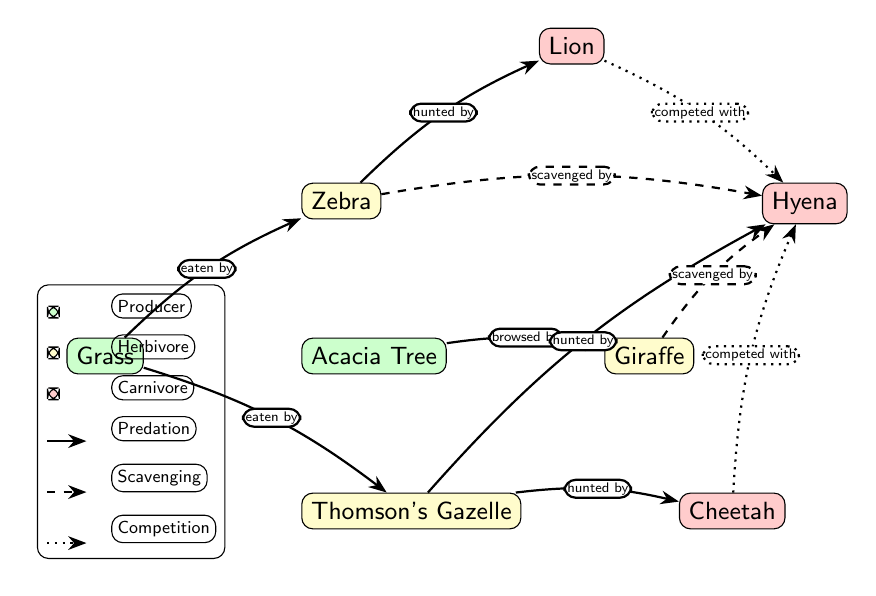What are the producers in the diagram? The diagram includes two producers: Grass and Acacia Tree. These are located at the beginning of the food chain and do not have any incoming edges.
Answer: Grass, Acacia Tree How many herbivores are represented? There are three herbivores shown in the diagram: Zebra, Thomson's Gazelle, and Giraffe, which consume the producers.
Answer: 3 What is the relationship between the Zebra and the Lion? The relationship is that the Lion hunts the Zebra, which is indicated by a solid edge pointing from the Zebra to the Lion in the diagram.
Answer: hunted by Which carnivore is directly competing with the Hyena? The diagram shows both the Lion and the Cheetah are in competition with the Hyena, as there are dotted arrows indicating competition from both.
Answer: Lion, Cheetah What does the dashed arrow from the Zebra to the Hyena represent? The dashed arrow indicates that the Hyena scavenges on the Zebra, which suggests that Hyenas may consume Zebra that are already dead rather than hunting them themselves.
Answer: scavenged by What herbivore browses on the Acacia Tree? The Giraffe is the herbivore that browses on the Acacia Tree, as indicated by the directed edge from the Acacia Tree to the Giraffe.
Answer: Giraffe How many different types of relationships are shown in the diagram? The diagram illustrates three types of relationships: predation, scavenging, and competition, indicated by solid, dashed, and dotted arrows respectively.
Answer: 3 Which herbivore is hunted by both the Cheetah and the Hyena? Thomson's Gazelle is being hunted by both the Cheetah and the Hyena, as shown by the edges connecting both carnivores to the gazelle.
Answer: Thomson's Gazelle 